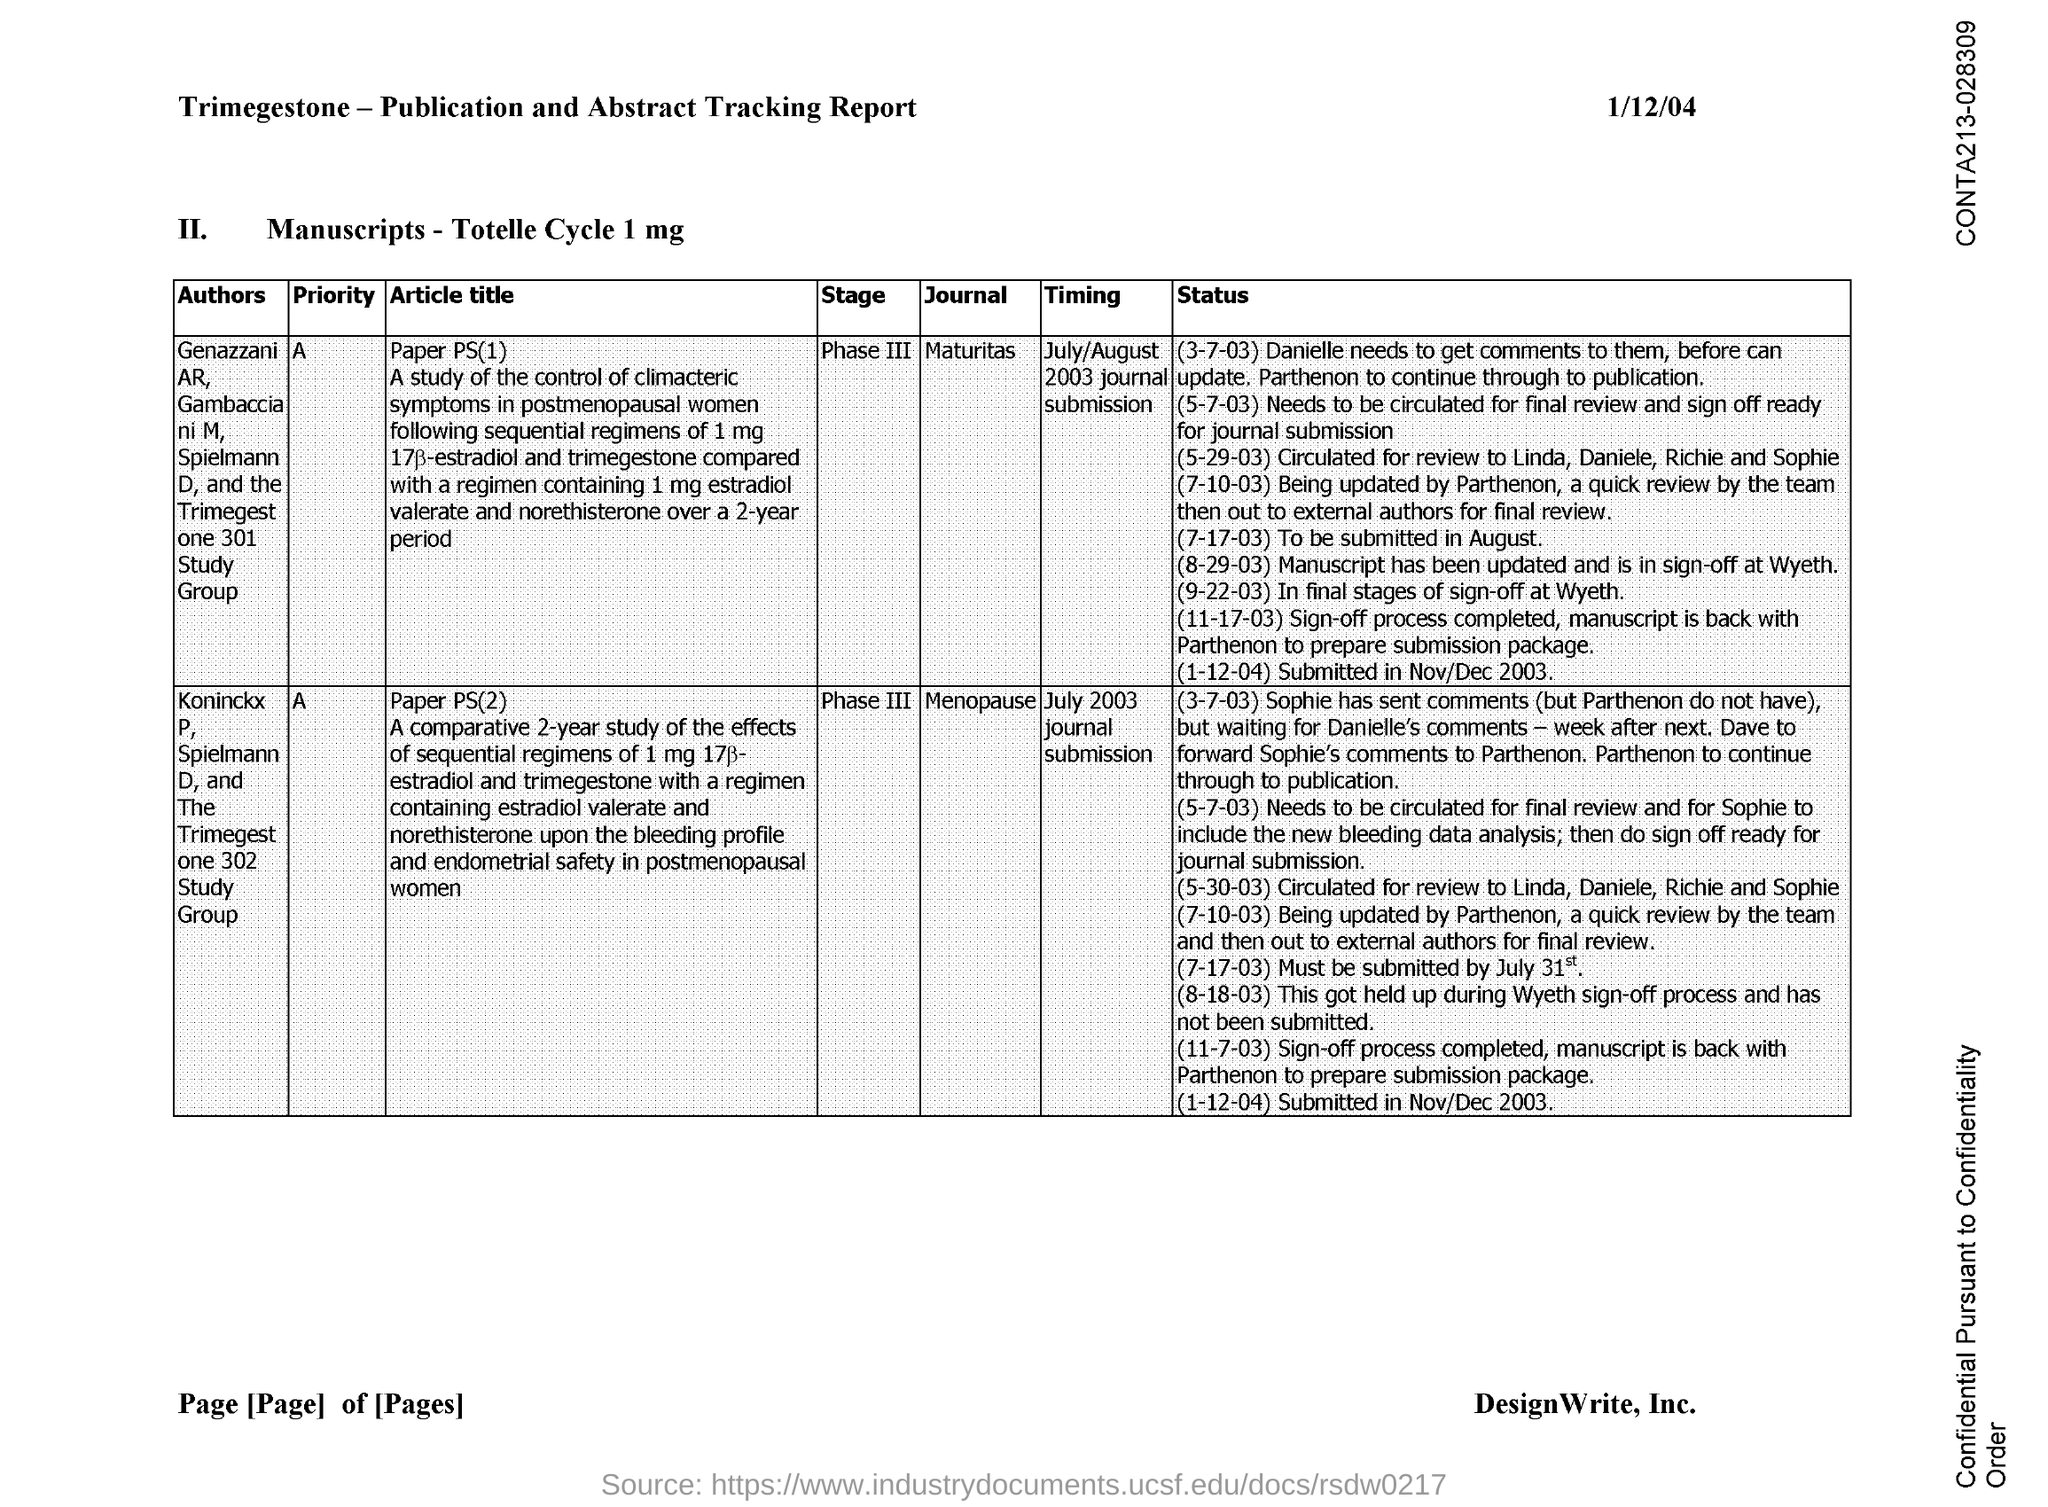Draw attention to some important aspects in this diagram. The journal "Maturitas" is a highly regarded publication in the field of gerontology, with a focus on research related to aging and the elderly. Its priority is to publish high-quality, original research that contributes to the advancement of knowledge in this area. TriMegestone-Publication and Abstract Tracking Report is the first title in this document. The journal Menopause is a highly prioritized publication in the field of women's health. 